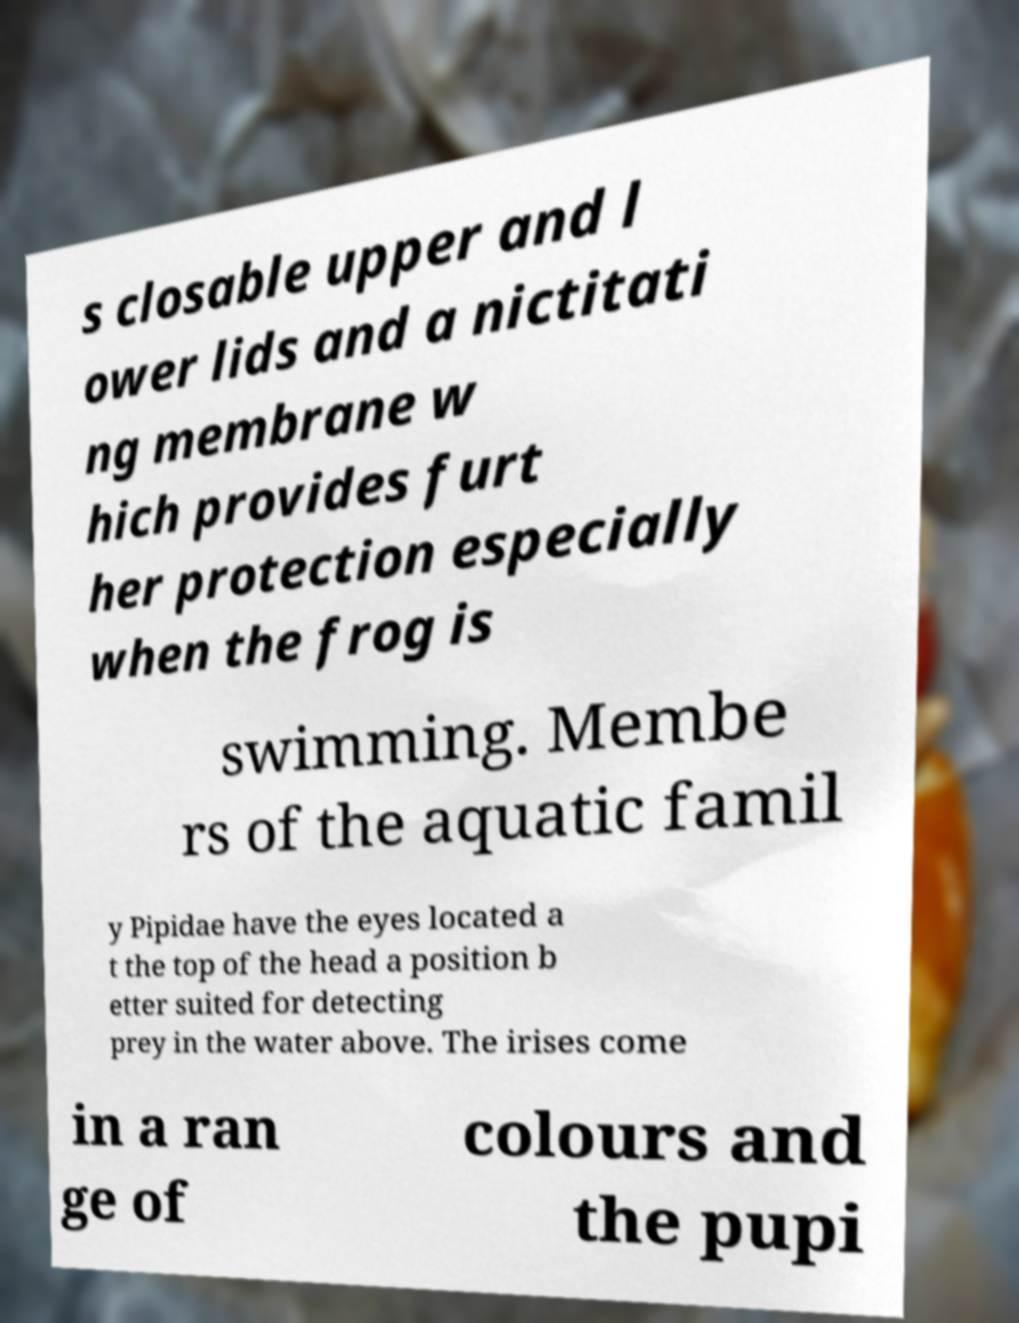Could you assist in decoding the text presented in this image and type it out clearly? s closable upper and l ower lids and a nictitati ng membrane w hich provides furt her protection especially when the frog is swimming. Membe rs of the aquatic famil y Pipidae have the eyes located a t the top of the head a position b etter suited for detecting prey in the water above. The irises come in a ran ge of colours and the pupi 